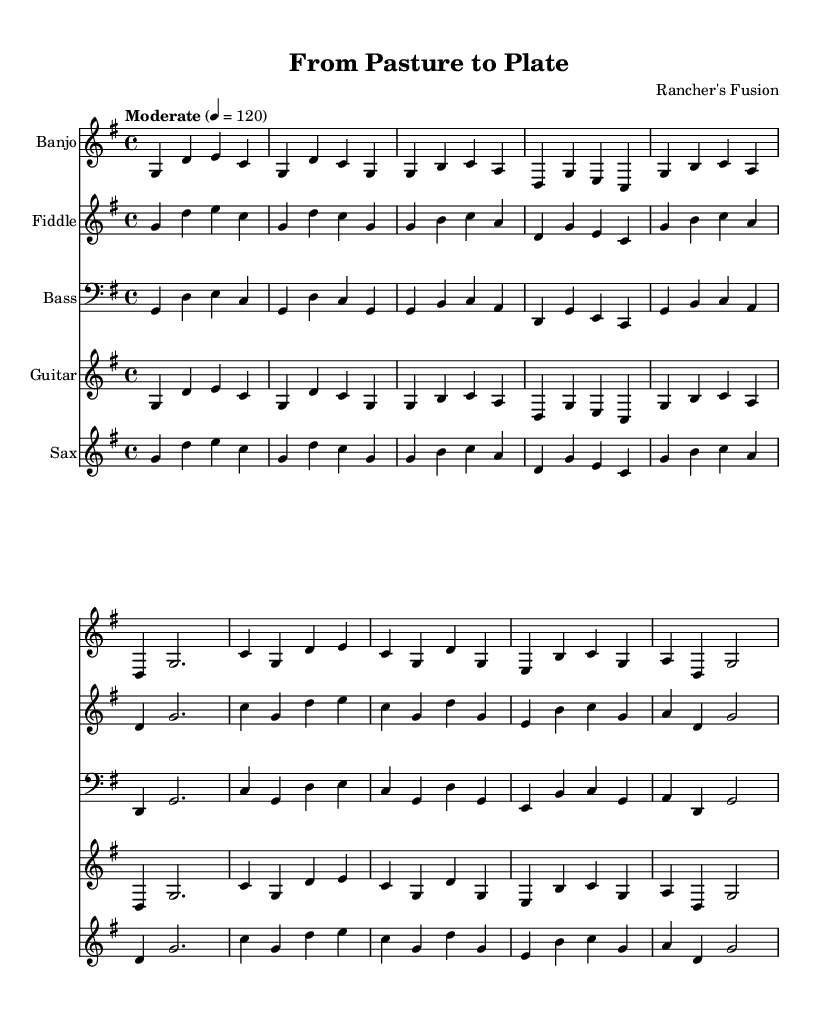What is the key signature of this music? The key signature shows one sharp, which indicates it is in the key of G major. G major consists of the notes G, A, B, C, D, E, and F#.
Answer: G major What is the time signature of this music? The time signature is shown at the beginning of the sheet music and is 4/4, meaning there are four beats in each measure and a quarter note gets one beat.
Answer: 4/4 What is the tempo marking for this piece? The tempo marking indicated is "Moderate" with a note value of 120 beats per minute. This refers to the speed at which the music is to be played.
Answer: Moderate 4 = 120 How many instruments are featured in this piece? By counting the number of staves in the score, five distinct instruments (banjo, fiddle, bass, guitar, and saxophone) are represented.
Answer: Five Which instrument has the first staff in the score? The first staff in the score is labeled as Banjo, meaning it is the first instrument that plays in this piece.
Answer: Banjo What is the note duration of the first measure for the banjo? The first measure contains four quarter notes: G, D, E, and C, indicating each note is held for one beat.
Answer: Four quarter notes What genre is this music genre categorized under? The combination of bluegrass and jazz elements signifies that this composition falls into the genre of bluegrass-jazz fusion, reflecting a blend of both styles.
Answer: Bluegrass-jazz fusion 